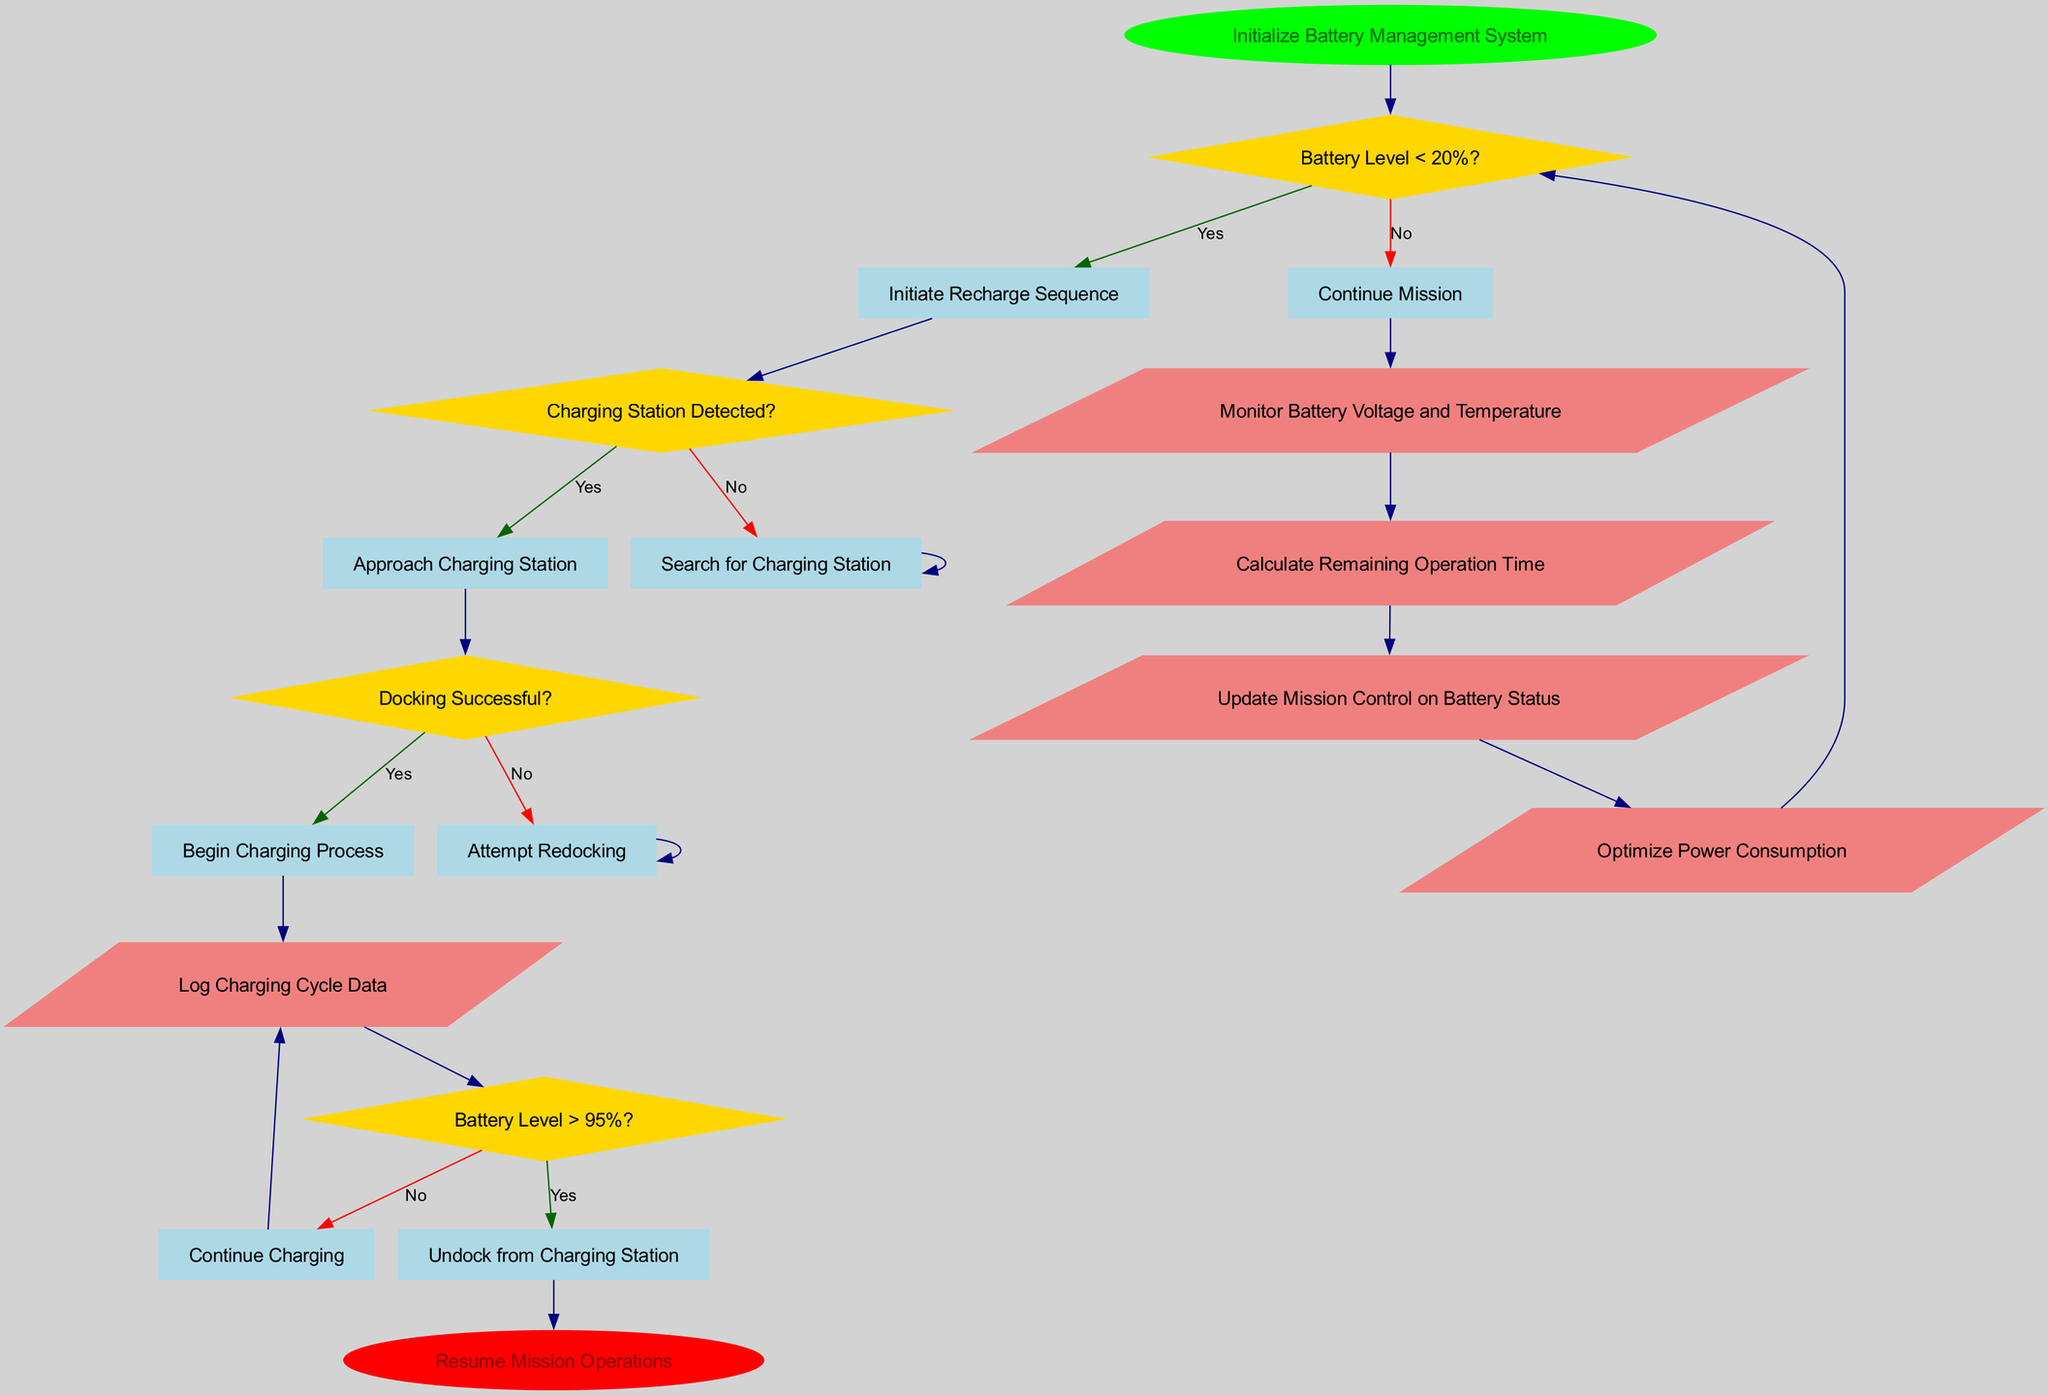What is the starting point of this flowchart? The flowchart begins at the "Initialize Battery Management System" node, indicated as the first operation in the sequence.
Answer: Initialize Battery Management System How many decision nodes are present in the diagram? There are four decision nodes, each representing a condition that leads to different paths based on yes or no answers.
Answer: 4 What happens if the battery level is less than 20%? If the battery level is below 20%, the process initiates a recharge sequence, as indicated by the flow from the first decision node's "yes" route.
Answer: Initiate Recharge Sequence What does the robot do if a charging station is not detected? If a charging station is not detected, the robot will search for a charging station, which is the action taken from the "no" side of the second decision node.
Answer: Search for Charging Station What is the action taken when the battery level exceeds 95%? When the battery level is greater than 95%, the flow chart specifies that the robot should undock from the charging station as indicated in the "yes" response of the fourth decision node.
Answer: Undock from Charging Station What processes occur after monitoring battery voltage and temperature? After monitoring voltage and temperature, the next process is to calculate the remaining operation time, indicating a sequential flow from one process to the other.
Answer: Calculate Remaining Operation Time In the case of unsuccessful docking, what is the subsequent action? If the docking is unsuccessful, the robot will attempt redocking, demonstrating a retry mechanism identified through the "no" response of the third decision node.
Answer: Attempt Redocking How many process nodes are included in the diagram? There are five process nodes, each detailing a specific action taken by the robot regarding battery status and management.
Answer: 5 What indicates the completion of the battery management flowchart? The end of the flowchart is indicated by the "Resume Mission Operations" node, marking the conclusion of the battery management routine.
Answer: Resume Mission Operations 